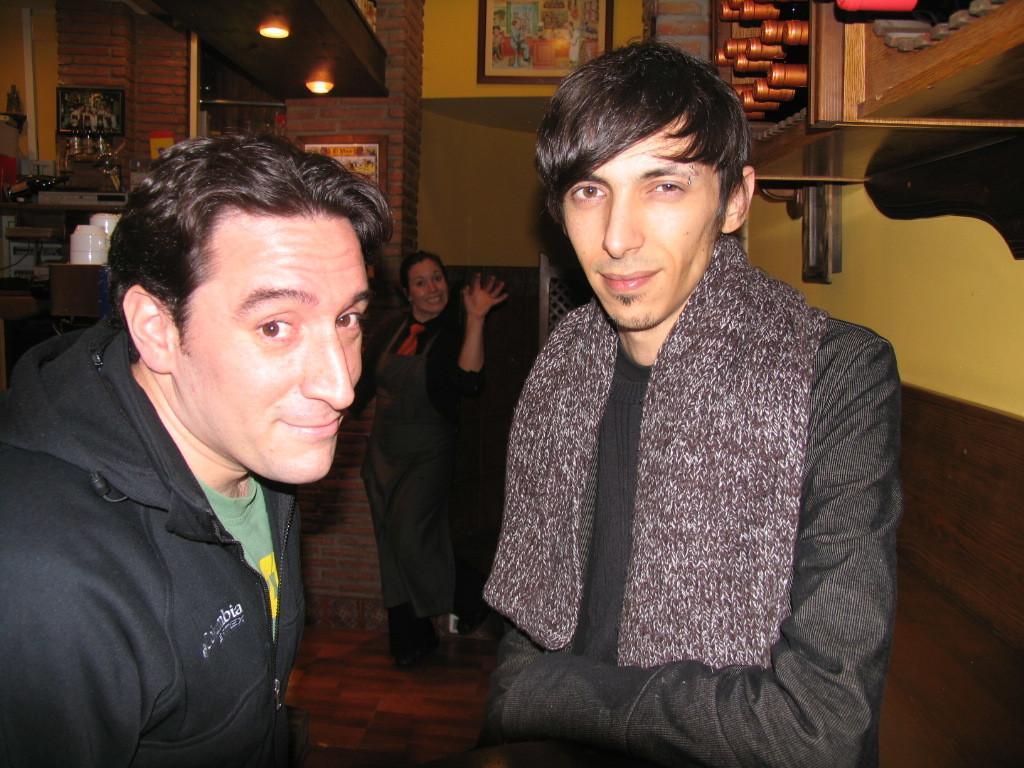In one or two sentences, can you explain what this image depicts? On the left side, there is a person in a black color jacket, smiling. On the right side, there is another person smiling. In the background, there is a woman smiling and showing a hand, there are lights attached to the roof, there are photo frames attached to the walls and there are other objects. 